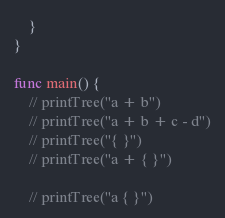Convert code to text. <code><loc_0><loc_0><loc_500><loc_500><_Go_>	}
}

func main() {
	// printTree("a + b")
	// printTree("a + b + c - d")
	// printTree("{ }")
	// printTree("a + { }")

	// printTree("a { }")</code> 